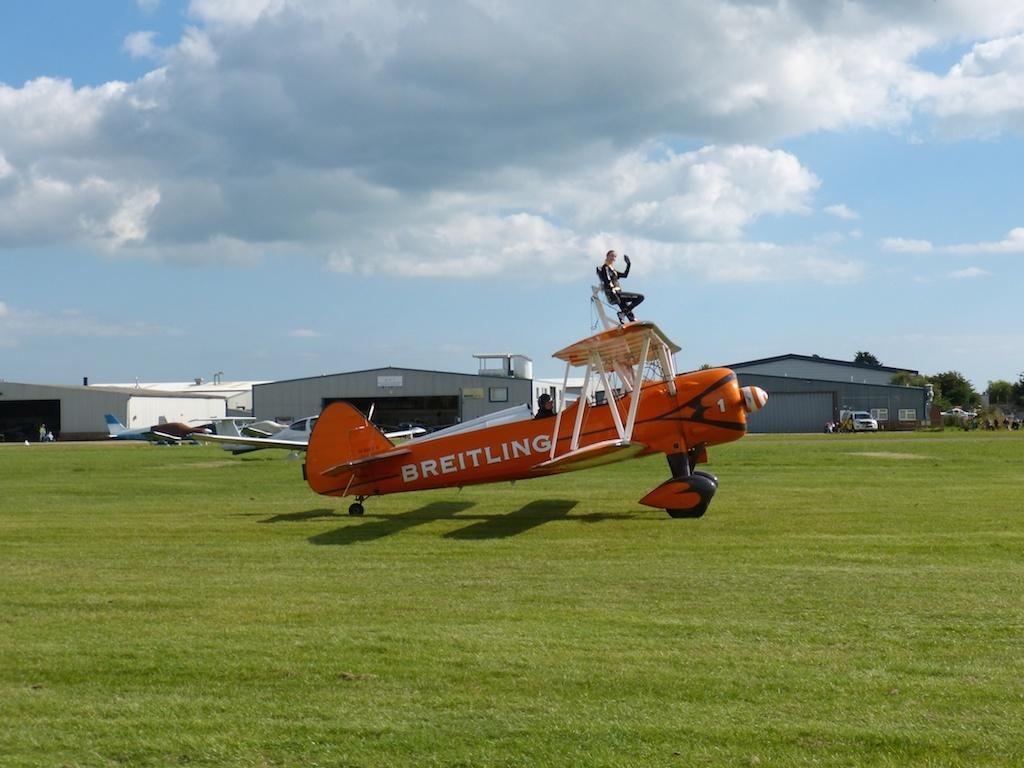<image>
Share a concise interpretation of the image provided. A woman sits on top of an orange Breitling airplane in a green field 